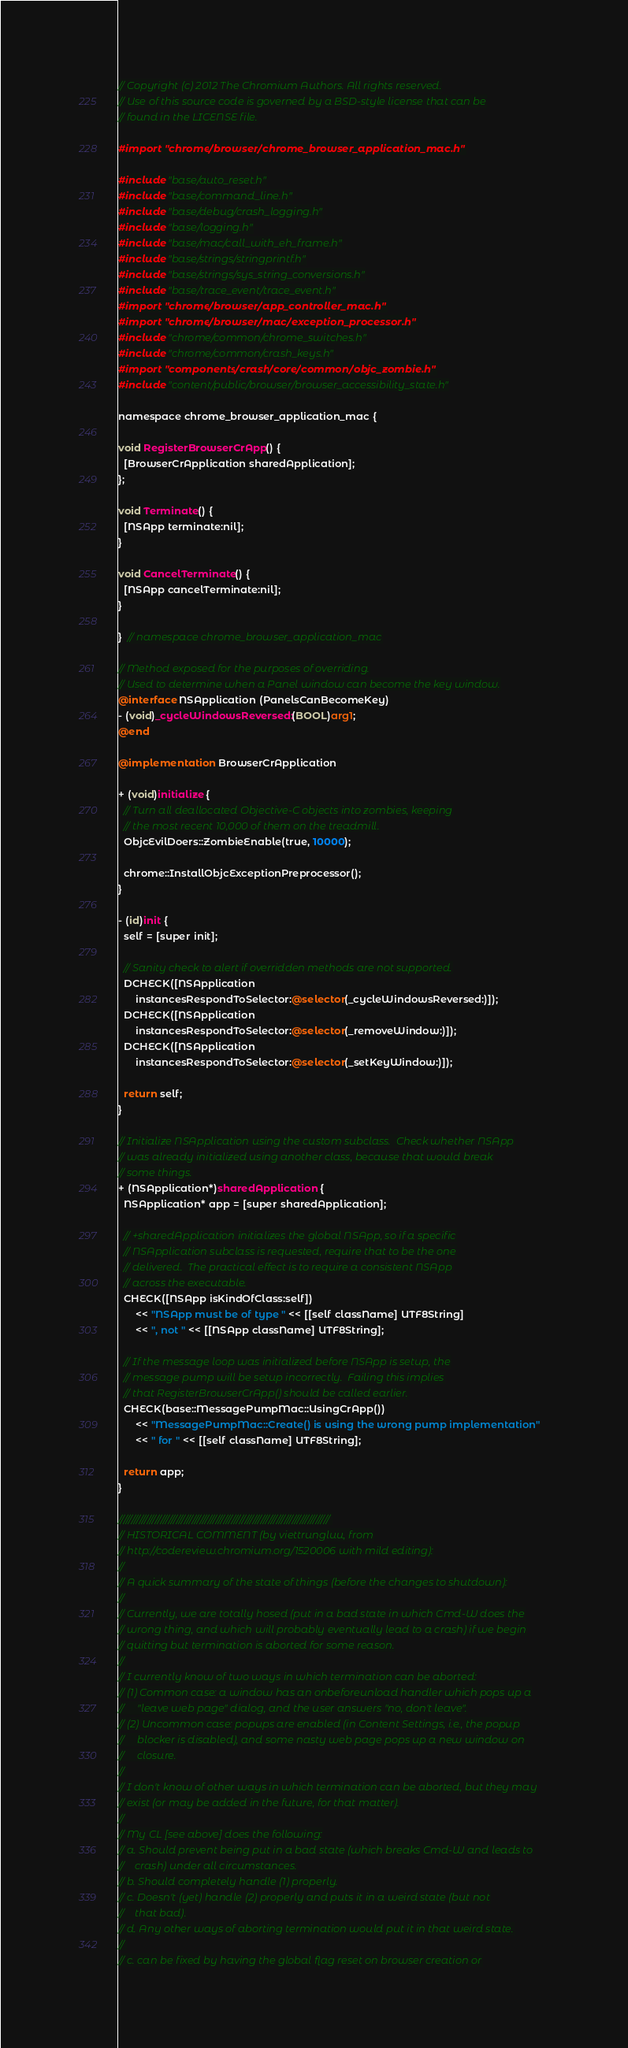Convert code to text. <code><loc_0><loc_0><loc_500><loc_500><_ObjectiveC_>// Copyright (c) 2012 The Chromium Authors. All rights reserved.
// Use of this source code is governed by a BSD-style license that can be
// found in the LICENSE file.

#import "chrome/browser/chrome_browser_application_mac.h"

#include "base/auto_reset.h"
#include "base/command_line.h"
#include "base/debug/crash_logging.h"
#include "base/logging.h"
#include "base/mac/call_with_eh_frame.h"
#include "base/strings/stringprintf.h"
#include "base/strings/sys_string_conversions.h"
#include "base/trace_event/trace_event.h"
#import "chrome/browser/app_controller_mac.h"
#import "chrome/browser/mac/exception_processor.h"
#include "chrome/common/chrome_switches.h"
#include "chrome/common/crash_keys.h"
#import "components/crash/core/common/objc_zombie.h"
#include "content/public/browser/browser_accessibility_state.h"

namespace chrome_browser_application_mac {

void RegisterBrowserCrApp() {
  [BrowserCrApplication sharedApplication];
};

void Terminate() {
  [NSApp terminate:nil];
}

void CancelTerminate() {
  [NSApp cancelTerminate:nil];
}

}  // namespace chrome_browser_application_mac

// Method exposed for the purposes of overriding.
// Used to determine when a Panel window can become the key window.
@interface NSApplication (PanelsCanBecomeKey)
- (void)_cycleWindowsReversed:(BOOL)arg1;
@end

@implementation BrowserCrApplication

+ (void)initialize {
  // Turn all deallocated Objective-C objects into zombies, keeping
  // the most recent 10,000 of them on the treadmill.
  ObjcEvilDoers::ZombieEnable(true, 10000);

  chrome::InstallObjcExceptionPreprocessor();
}

- (id)init {
  self = [super init];

  // Sanity check to alert if overridden methods are not supported.
  DCHECK([NSApplication
      instancesRespondToSelector:@selector(_cycleWindowsReversed:)]);
  DCHECK([NSApplication
      instancesRespondToSelector:@selector(_removeWindow:)]);
  DCHECK([NSApplication
      instancesRespondToSelector:@selector(_setKeyWindow:)]);

  return self;
}

// Initialize NSApplication using the custom subclass.  Check whether NSApp
// was already initialized using another class, because that would break
// some things.
+ (NSApplication*)sharedApplication {
  NSApplication* app = [super sharedApplication];

  // +sharedApplication initializes the global NSApp, so if a specific
  // NSApplication subclass is requested, require that to be the one
  // delivered.  The practical effect is to require a consistent NSApp
  // across the executable.
  CHECK([NSApp isKindOfClass:self])
      << "NSApp must be of type " << [[self className] UTF8String]
      << ", not " << [[NSApp className] UTF8String];

  // If the message loop was initialized before NSApp is setup, the
  // message pump will be setup incorrectly.  Failing this implies
  // that RegisterBrowserCrApp() should be called earlier.
  CHECK(base::MessagePumpMac::UsingCrApp())
      << "MessagePumpMac::Create() is using the wrong pump implementation"
      << " for " << [[self className] UTF8String];

  return app;
}

////////////////////////////////////////////////////////////////////////////////
// HISTORICAL COMMENT (by viettrungluu, from
// http://codereview.chromium.org/1520006 with mild editing):
//
// A quick summary of the state of things (before the changes to shutdown):
//
// Currently, we are totally hosed (put in a bad state in which Cmd-W does the
// wrong thing, and which will probably eventually lead to a crash) if we begin
// quitting but termination is aborted for some reason.
//
// I currently know of two ways in which termination can be aborted:
// (1) Common case: a window has an onbeforeunload handler which pops up a
//     "leave web page" dialog, and the user answers "no, don't leave".
// (2) Uncommon case: popups are enabled (in Content Settings, i.e., the popup
//     blocker is disabled), and some nasty web page pops up a new window on
//     closure.
//
// I don't know of other ways in which termination can be aborted, but they may
// exist (or may be added in the future, for that matter).
//
// My CL [see above] does the following:
// a. Should prevent being put in a bad state (which breaks Cmd-W and leads to
//    crash) under all circumstances.
// b. Should completely handle (1) properly.
// c. Doesn't (yet) handle (2) properly and puts it in a weird state (but not
//    that bad).
// d. Any other ways of aborting termination would put it in that weird state.
//
// c. can be fixed by having the global flag reset on browser creation or</code> 